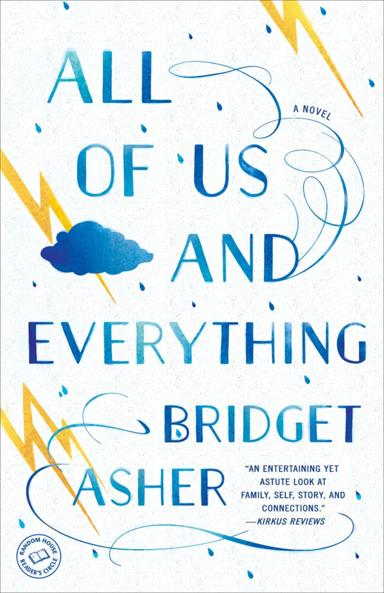What is the tone of the novel according to the review? According to a review by Kirkus Reviews, the novel has an entertaining yet astute tone, skillfully blending humor with insightful observations about life and relationships. 